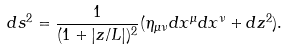<formula> <loc_0><loc_0><loc_500><loc_500>d s ^ { 2 } = \frac { 1 } { ( 1 + | z / L | ) ^ { 2 } } ( \eta _ { \mu \nu } d x ^ { \mu } d x ^ { \nu } + d z ^ { 2 } ) .</formula> 